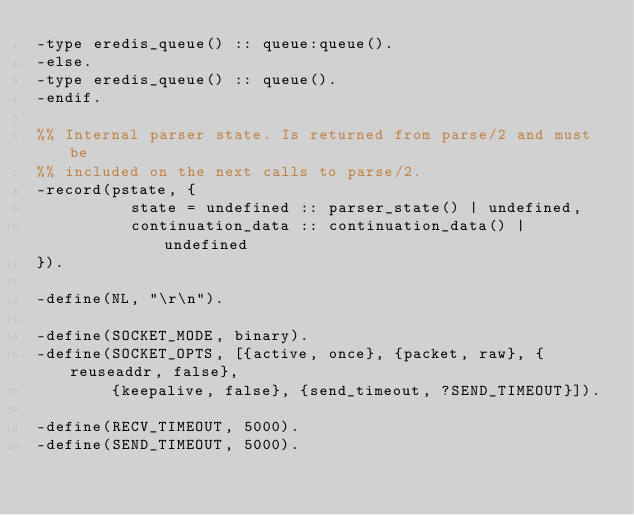<code> <loc_0><loc_0><loc_500><loc_500><_Erlang_>-type eredis_queue() :: queue:queue().
-else.
-type eredis_queue() :: queue().
-endif.

%% Internal parser state. Is returned from parse/2 and must be
%% included on the next calls to parse/2.
-record(pstate, {
          state = undefined :: parser_state() | undefined,
          continuation_data :: continuation_data() | undefined
}).

-define(NL, "\r\n").

-define(SOCKET_MODE, binary).
-define(SOCKET_OPTS, [{active, once}, {packet, raw}, {reuseaddr, false},
        {keepalive, false}, {send_timeout, ?SEND_TIMEOUT}]).

-define(RECV_TIMEOUT, 5000).
-define(SEND_TIMEOUT, 5000).
</code> 